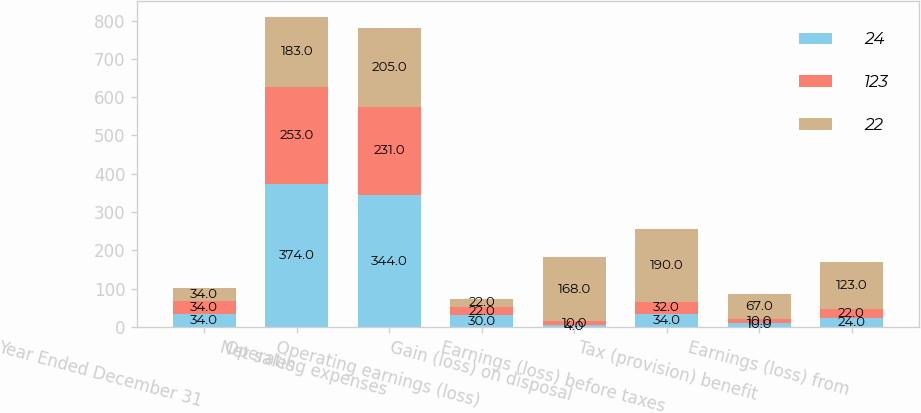Convert chart to OTSL. <chart><loc_0><loc_0><loc_500><loc_500><stacked_bar_chart><ecel><fcel>Year Ended December 31<fcel>Net sales<fcel>Operating expenses<fcel>Operating earnings (loss)<fcel>Gain (loss) on disposal<fcel>Earnings (loss) before taxes<fcel>Tax (provision) benefit<fcel>Earnings (loss) from<nl><fcel>24<fcel>34<fcel>374<fcel>344<fcel>30<fcel>4<fcel>34<fcel>10<fcel>24<nl><fcel>123<fcel>34<fcel>253<fcel>231<fcel>22<fcel>10<fcel>32<fcel>10<fcel>22<nl><fcel>22<fcel>34<fcel>183<fcel>205<fcel>22<fcel>168<fcel>190<fcel>67<fcel>123<nl></chart> 